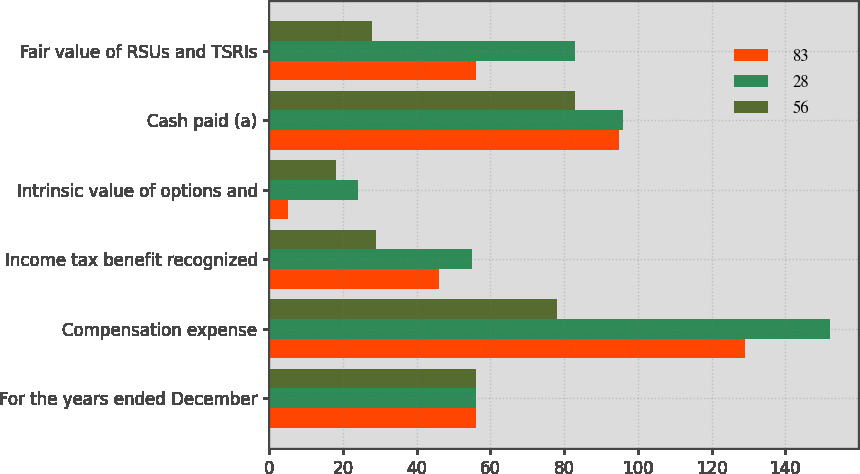Convert chart to OTSL. <chart><loc_0><loc_0><loc_500><loc_500><stacked_bar_chart><ecel><fcel>For the years ended December<fcel>Compensation expense<fcel>Income tax benefit recognized<fcel>Intrinsic value of options and<fcel>Cash paid (a)<fcel>Fair value of RSUs and TSRIs<nl><fcel>83<fcel>56<fcel>129<fcel>46<fcel>5<fcel>95<fcel>56<nl><fcel>28<fcel>56<fcel>152<fcel>55<fcel>24<fcel>96<fcel>83<nl><fcel>56<fcel>56<fcel>78<fcel>29<fcel>18<fcel>83<fcel>28<nl></chart> 